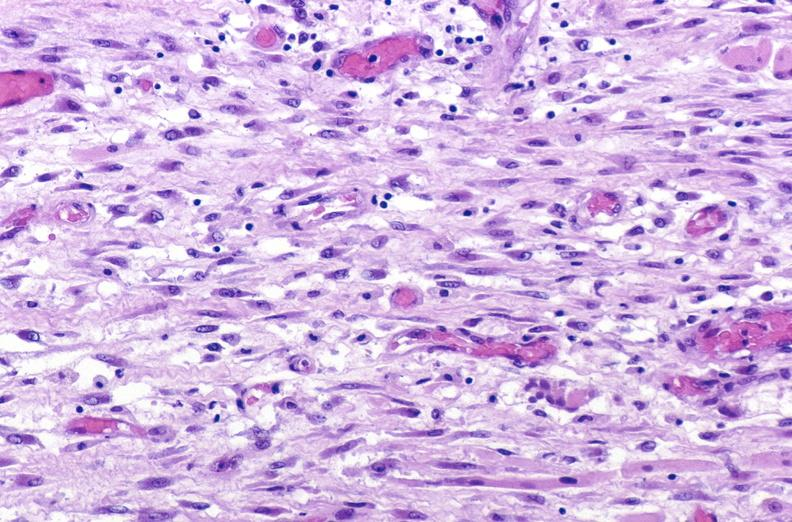what does this image show?
Answer the question using a single word or phrase. Tracheotomy site 